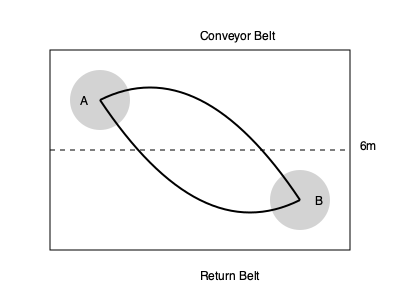In a meat packing plant, a conveyor belt system is set up as shown in the diagram. The distance between rollers A and B is 6 meters. If the conveyor belt moves at a speed of 0.5 meters per second, how long does it take for a piece of meat to travel from roller A to roller B? To solve this problem, we need to follow these steps:

1. Recognize that the path of the meat is not a straight line, but follows the curve of the conveyor belt.

2. Estimate the length of the curved path. In this case, we can approximate it as half the circumference of an ellipse.

3. The formula for the circumference of an ellipse is approximately:
   $$C \approx 2\pi\sqrt{\frac{a^2 + b^2}{2}}$$
   where $a$ and $b$ are the semi-major and semi-minor axes.

4. In our case:
   $a = 3$ meters (half the horizontal distance)
   $b = 1.5$ meters (estimated vertical distance)

5. Plugging these values into the formula:
   $$C \approx 2\pi\sqrt{\frac{3^2 + 1.5^2}{2}} \approx 14.13\text{ meters}$$

6. We're interested in half of this circumference:
   $$\text{Path length} \approx \frac{14.13}{2} \approx 7.07\text{ meters}$$

7. Given the speed of 0.5 meters per second, we can calculate the time:
   $$\text{Time} = \frac{\text{Distance}}{\text{Speed}} = \frac{7.07\text{ m}}{0.5\text{ m/s}} \approx 14.14\text{ seconds}$$

Therefore, it takes approximately 14.14 seconds for a piece of meat to travel from roller A to roller B.
Answer: 14.14 seconds 